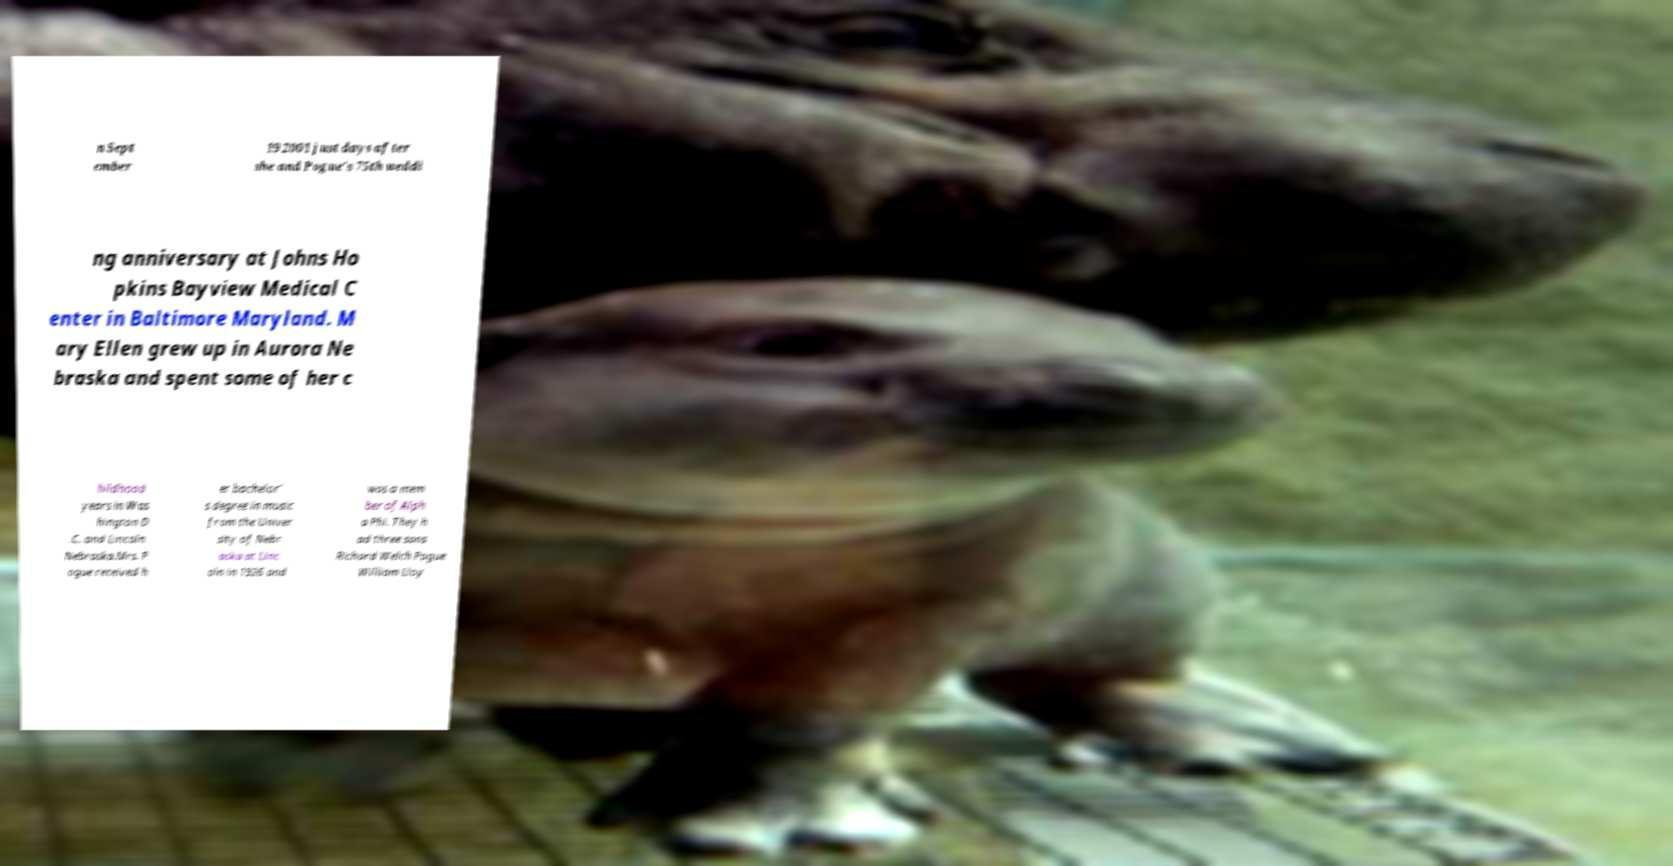Please identify and transcribe the text found in this image. n Sept ember 19 2001 just days after she and Pogue's 75th weddi ng anniversary at Johns Ho pkins Bayview Medical C enter in Baltimore Maryland. M ary Ellen grew up in Aurora Ne braska and spent some of her c hildhood years in Was hington D .C. and Lincoln Nebraska.Mrs. P ogue received h er bachelor' s degree in music from the Univer sity of Nebr aska at Linc oln in 1926 and was a mem ber of Alph a Phi. They h ad three sons Richard Welch Pogue William Lloy 